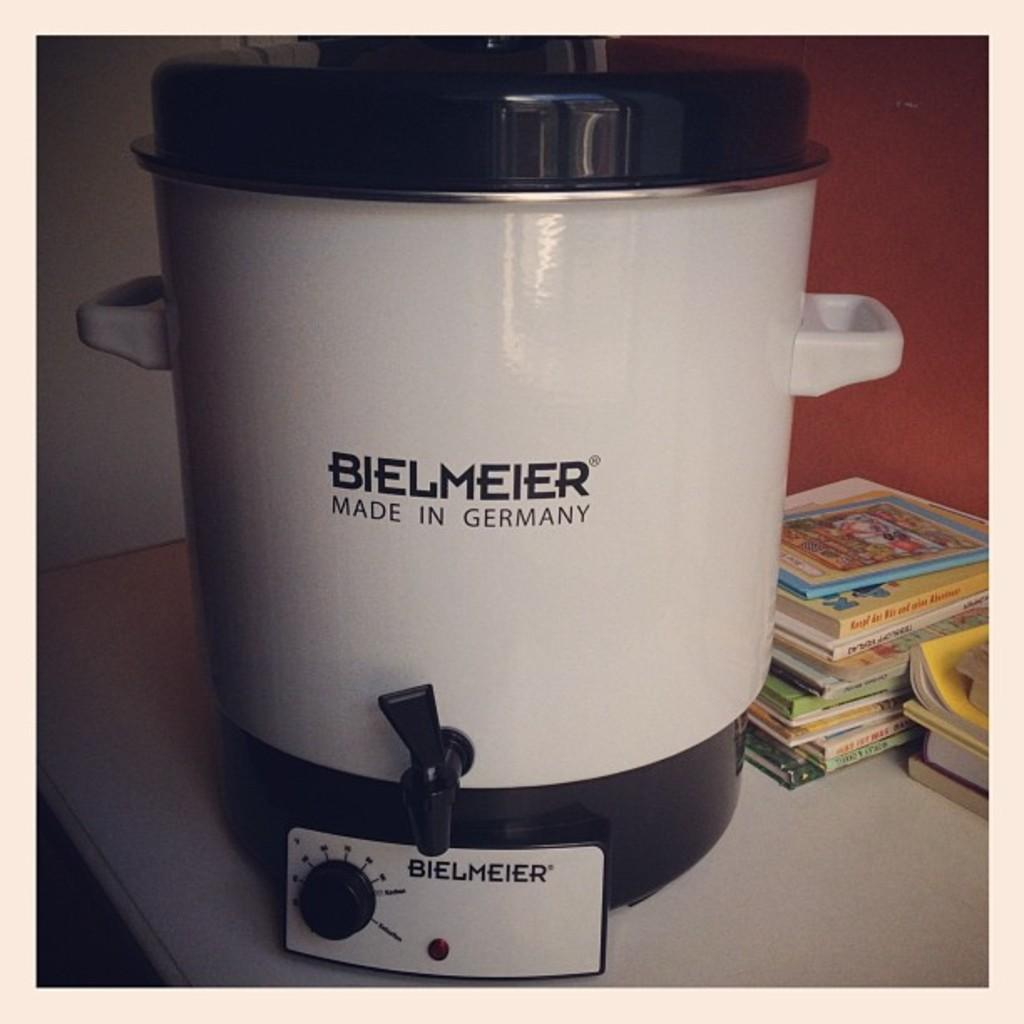<image>
Create a compact narrative representing the image presented. A large white and black item labeled Bielmeier on a table next to a stack of books. 